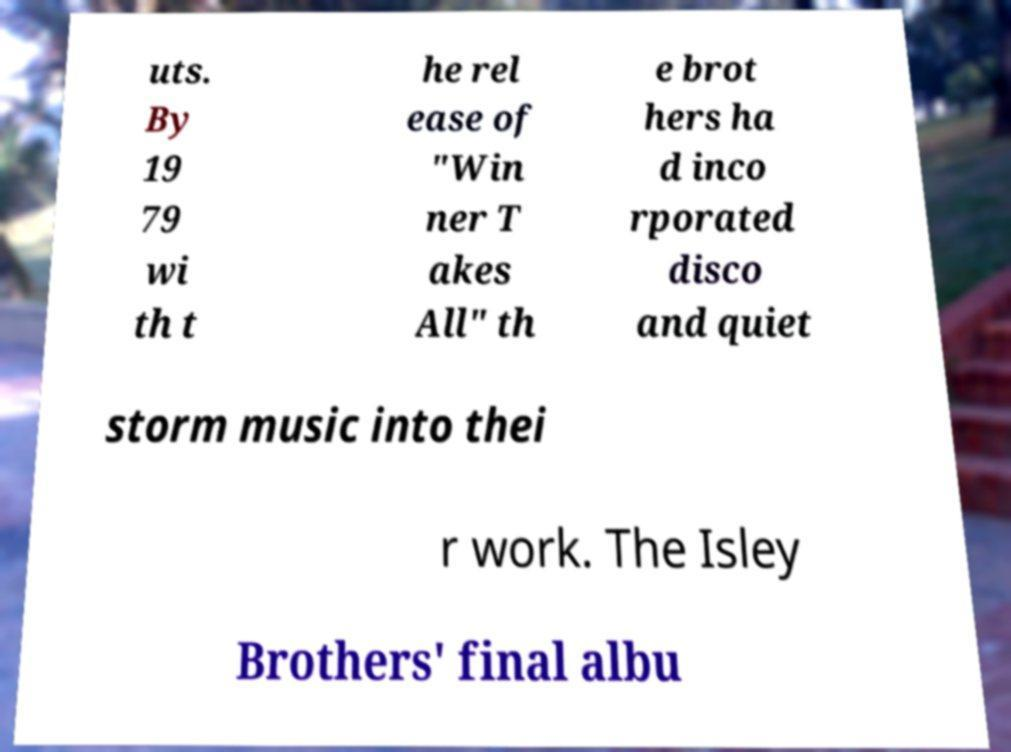Could you extract and type out the text from this image? uts. By 19 79 wi th t he rel ease of "Win ner T akes All" th e brot hers ha d inco rporated disco and quiet storm music into thei r work. The Isley Brothers' final albu 